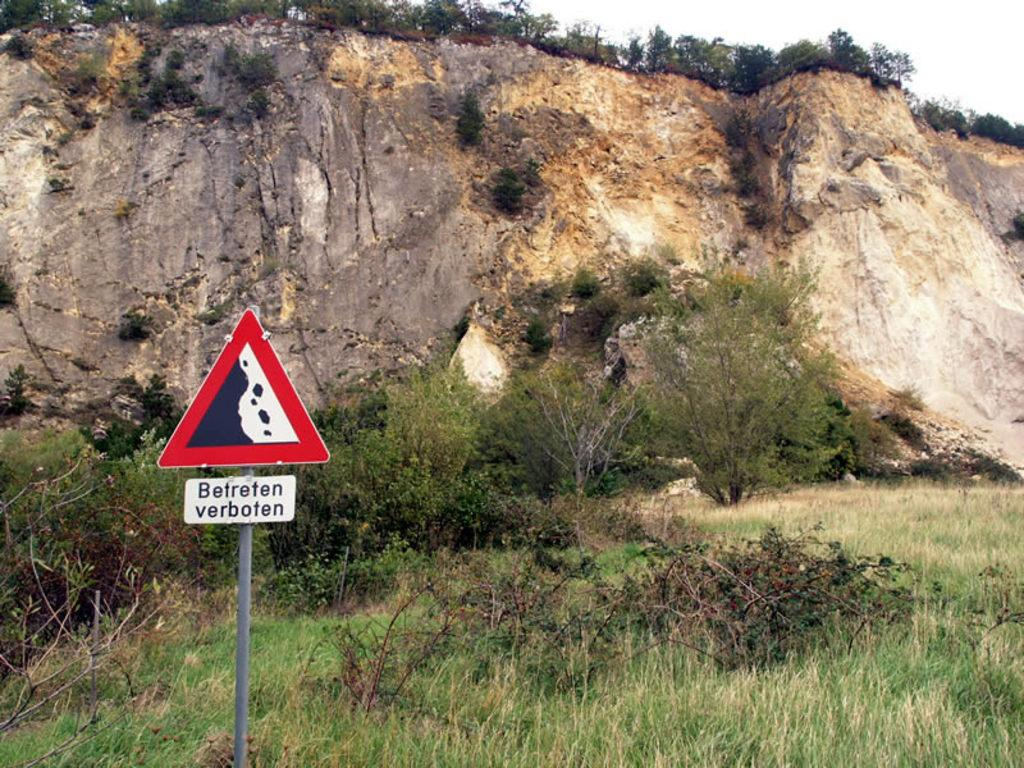<image>
Share a concise interpretation of the image provided. White sign that has words which says "Betreten Verboten" by a mountain. 